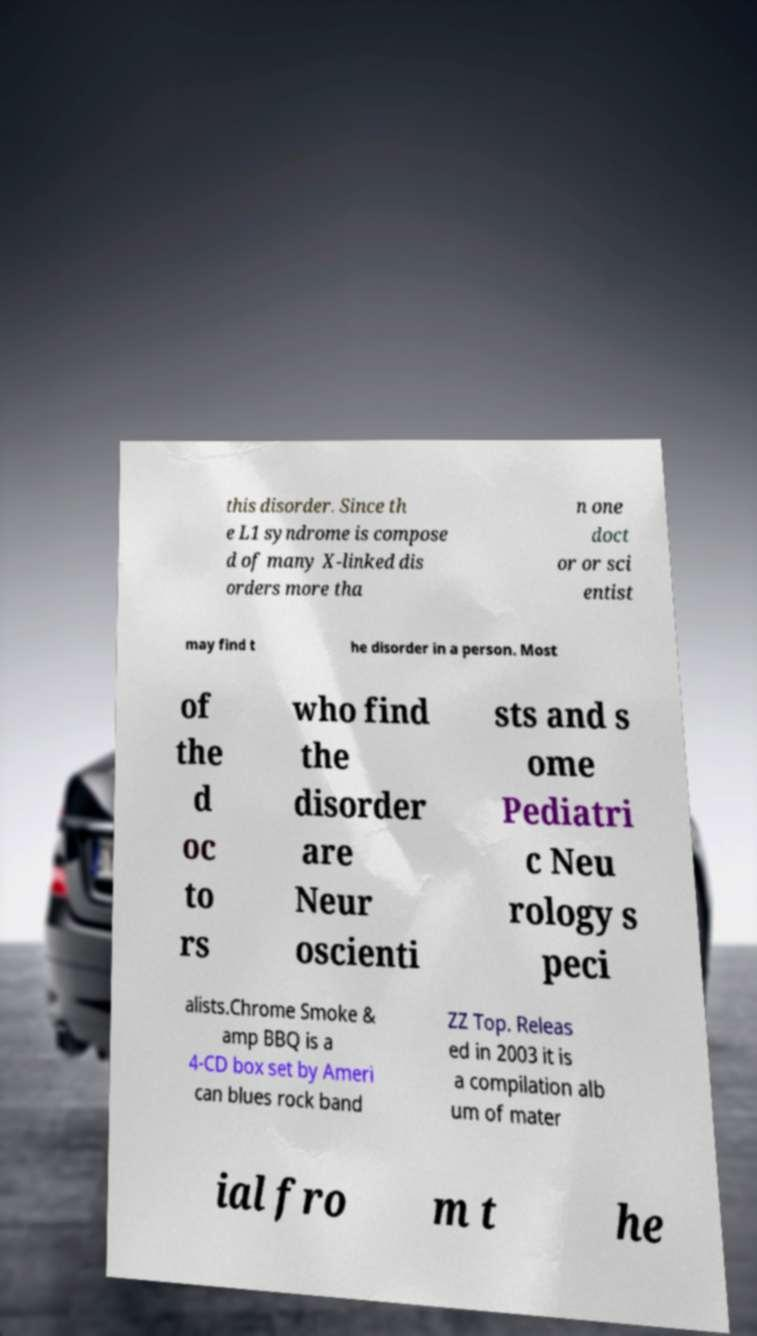Please identify and transcribe the text found in this image. this disorder. Since th e L1 syndrome is compose d of many X-linked dis orders more tha n one doct or or sci entist may find t he disorder in a person. Most of the d oc to rs who find the disorder are Neur oscienti sts and s ome Pediatri c Neu rology s peci alists.Chrome Smoke & amp BBQ is a 4-CD box set by Ameri can blues rock band ZZ Top. Releas ed in 2003 it is a compilation alb um of mater ial fro m t he 